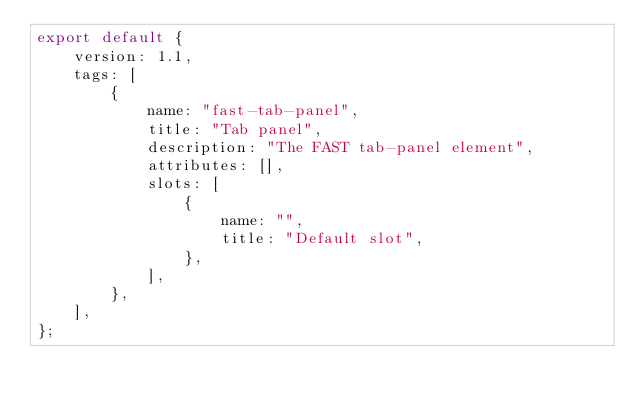Convert code to text. <code><loc_0><loc_0><loc_500><loc_500><_TypeScript_>export default {
    version: 1.1,
    tags: [
        {
            name: "fast-tab-panel",
            title: "Tab panel",
            description: "The FAST tab-panel element",
            attributes: [],
            slots: [
                {
                    name: "",
                    title: "Default slot",
                },
            ],
        },
    ],
};
</code> 